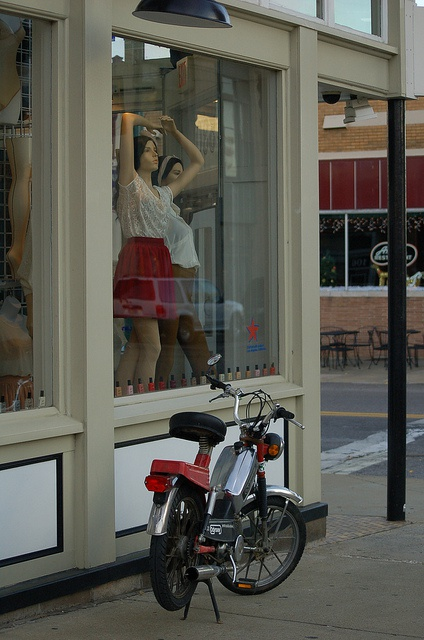Describe the objects in this image and their specific colors. I can see motorcycle in gray, black, darkgray, and maroon tones, people in gray, maroon, and black tones, people in gray, black, and maroon tones, chair in gray and black tones, and chair in gray and black tones in this image. 